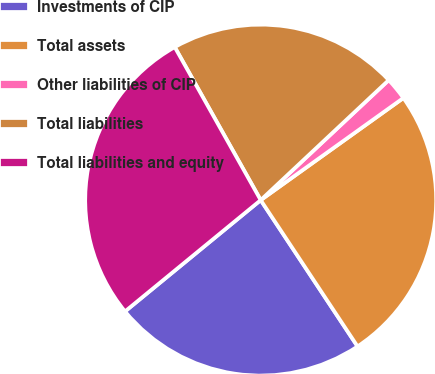Convert chart. <chart><loc_0><loc_0><loc_500><loc_500><pie_chart><fcel>Investments of CIP<fcel>Total assets<fcel>Other liabilities of CIP<fcel>Total liabilities<fcel>Total liabilities and equity<nl><fcel>23.37%<fcel>25.58%<fcel>2.1%<fcel>21.16%<fcel>27.79%<nl></chart> 